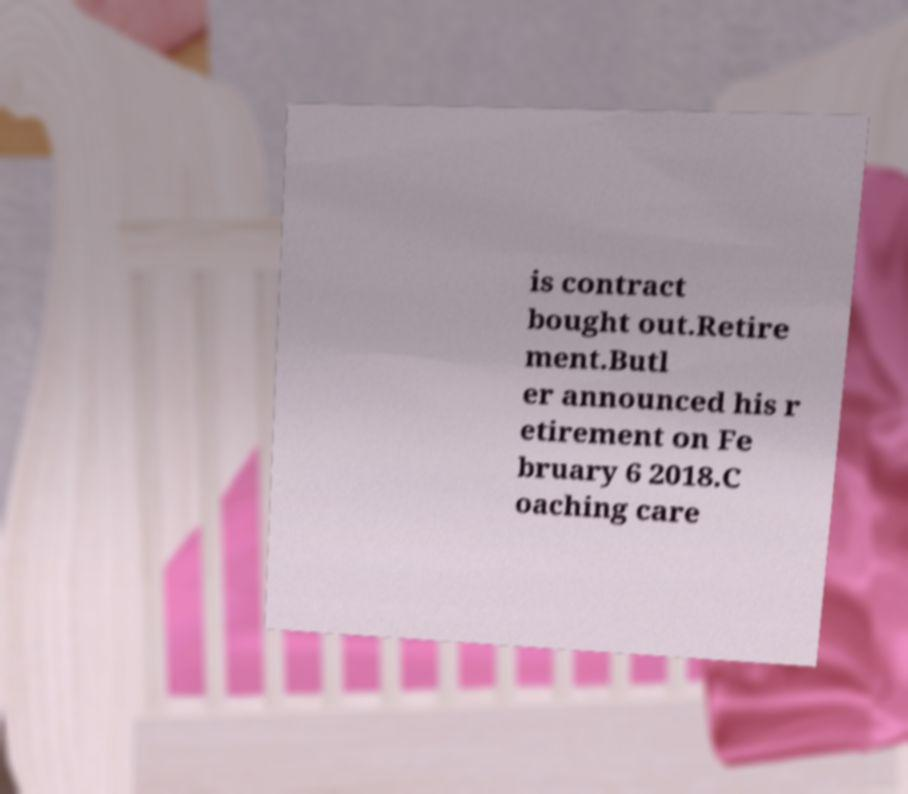What messages or text are displayed in this image? I need them in a readable, typed format. is contract bought out.Retire ment.Butl er announced his r etirement on Fe bruary 6 2018.C oaching care 